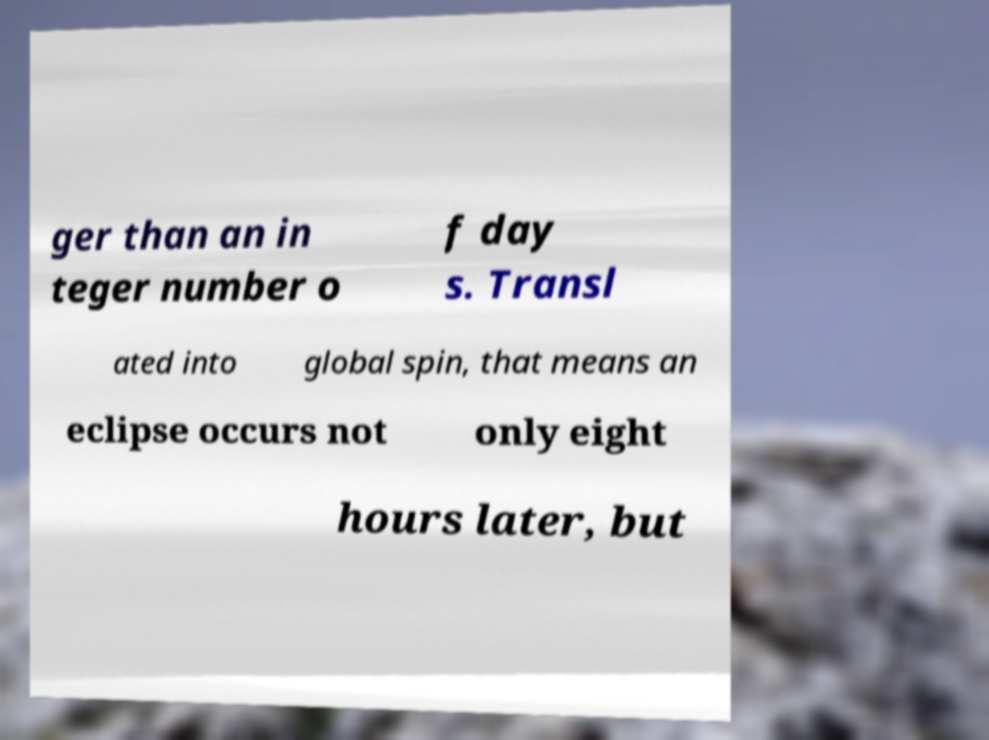Please identify and transcribe the text found in this image. ger than an in teger number o f day s. Transl ated into global spin, that means an eclipse occurs not only eight hours later, but 